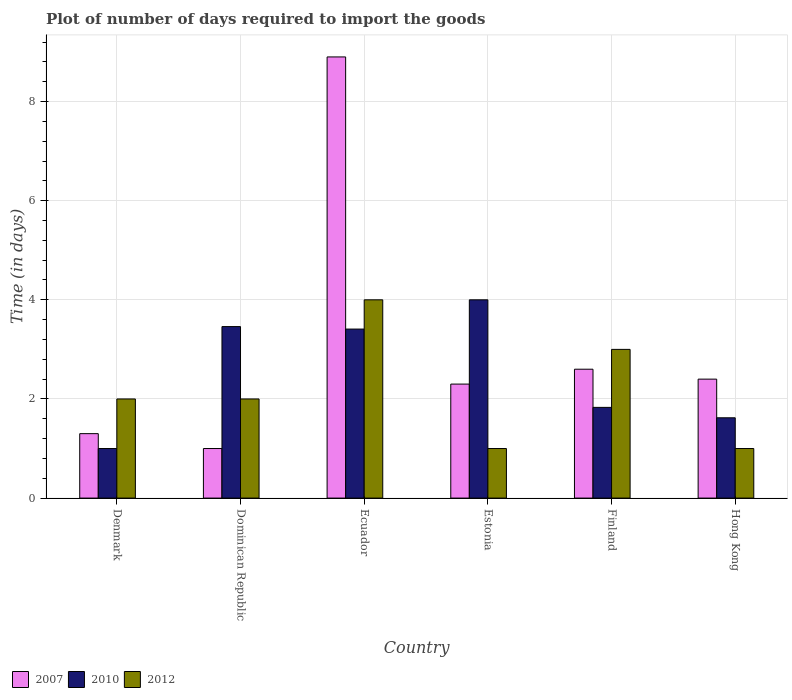How many bars are there on the 1st tick from the right?
Your answer should be compact. 3. What is the label of the 6th group of bars from the left?
Ensure brevity in your answer.  Hong Kong. Across all countries, what is the minimum time required to import goods in 2010?
Give a very brief answer. 1. In which country was the time required to import goods in 2007 maximum?
Provide a succinct answer. Ecuador. In which country was the time required to import goods in 2010 minimum?
Offer a very short reply. Denmark. What is the difference between the time required to import goods in 2007 in Ecuador and that in Estonia?
Your response must be concise. 6.6. What is the difference between the time required to import goods in 2012 in Denmark and the time required to import goods in 2010 in Ecuador?
Provide a succinct answer. -1.41. What is the average time required to import goods in 2010 per country?
Offer a terse response. 2.55. What is the difference between the time required to import goods of/in 2010 and time required to import goods of/in 2007 in Dominican Republic?
Provide a succinct answer. 2.46. What is the ratio of the time required to import goods in 2007 in Estonia to that in Hong Kong?
Your answer should be very brief. 0.96. Is the time required to import goods in 2012 in Denmark less than that in Dominican Republic?
Your answer should be compact. No. Is the difference between the time required to import goods in 2010 in Ecuador and Hong Kong greater than the difference between the time required to import goods in 2007 in Ecuador and Hong Kong?
Provide a succinct answer. No. What is the difference between the highest and the second highest time required to import goods in 2010?
Offer a very short reply. -0.05. What is the difference between the highest and the lowest time required to import goods in 2010?
Offer a very short reply. 3. In how many countries, is the time required to import goods in 2012 greater than the average time required to import goods in 2012 taken over all countries?
Ensure brevity in your answer.  2. How many bars are there?
Ensure brevity in your answer.  18. Does the graph contain grids?
Your answer should be compact. Yes. How many legend labels are there?
Offer a very short reply. 3. How are the legend labels stacked?
Give a very brief answer. Horizontal. What is the title of the graph?
Ensure brevity in your answer.  Plot of number of days required to import the goods. Does "2003" appear as one of the legend labels in the graph?
Provide a succinct answer. No. What is the label or title of the X-axis?
Offer a terse response. Country. What is the label or title of the Y-axis?
Your answer should be compact. Time (in days). What is the Time (in days) of 2007 in Denmark?
Your answer should be very brief. 1.3. What is the Time (in days) of 2007 in Dominican Republic?
Your response must be concise. 1. What is the Time (in days) of 2010 in Dominican Republic?
Ensure brevity in your answer.  3.46. What is the Time (in days) of 2007 in Ecuador?
Make the answer very short. 8.9. What is the Time (in days) in 2010 in Ecuador?
Your answer should be very brief. 3.41. What is the Time (in days) of 2007 in Estonia?
Provide a succinct answer. 2.3. What is the Time (in days) of 2010 in Estonia?
Your response must be concise. 4. What is the Time (in days) of 2012 in Estonia?
Give a very brief answer. 1. What is the Time (in days) of 2010 in Finland?
Keep it short and to the point. 1.83. What is the Time (in days) of 2010 in Hong Kong?
Offer a very short reply. 1.62. What is the Time (in days) in 2012 in Hong Kong?
Your answer should be compact. 1. Across all countries, what is the maximum Time (in days) of 2010?
Make the answer very short. 4. What is the total Time (in days) in 2010 in the graph?
Offer a very short reply. 15.32. What is the total Time (in days) of 2012 in the graph?
Your answer should be very brief. 13. What is the difference between the Time (in days) of 2007 in Denmark and that in Dominican Republic?
Your answer should be compact. 0.3. What is the difference between the Time (in days) in 2010 in Denmark and that in Dominican Republic?
Your response must be concise. -2.46. What is the difference between the Time (in days) of 2012 in Denmark and that in Dominican Republic?
Your answer should be compact. 0. What is the difference between the Time (in days) of 2010 in Denmark and that in Ecuador?
Offer a terse response. -2.41. What is the difference between the Time (in days) in 2012 in Denmark and that in Ecuador?
Your answer should be compact. -2. What is the difference between the Time (in days) of 2010 in Denmark and that in Finland?
Your answer should be compact. -0.83. What is the difference between the Time (in days) of 2012 in Denmark and that in Finland?
Your answer should be compact. -1. What is the difference between the Time (in days) of 2007 in Denmark and that in Hong Kong?
Ensure brevity in your answer.  -1.1. What is the difference between the Time (in days) of 2010 in Denmark and that in Hong Kong?
Provide a short and direct response. -0.62. What is the difference between the Time (in days) of 2012 in Denmark and that in Hong Kong?
Ensure brevity in your answer.  1. What is the difference between the Time (in days) of 2007 in Dominican Republic and that in Ecuador?
Make the answer very short. -7.9. What is the difference between the Time (in days) of 2012 in Dominican Republic and that in Ecuador?
Your answer should be very brief. -2. What is the difference between the Time (in days) of 2007 in Dominican Republic and that in Estonia?
Provide a short and direct response. -1.3. What is the difference between the Time (in days) of 2010 in Dominican Republic and that in Estonia?
Your answer should be very brief. -0.54. What is the difference between the Time (in days) of 2012 in Dominican Republic and that in Estonia?
Offer a very short reply. 1. What is the difference between the Time (in days) of 2007 in Dominican Republic and that in Finland?
Your answer should be very brief. -1.6. What is the difference between the Time (in days) of 2010 in Dominican Republic and that in Finland?
Your response must be concise. 1.63. What is the difference between the Time (in days) in 2012 in Dominican Republic and that in Finland?
Keep it short and to the point. -1. What is the difference between the Time (in days) in 2007 in Dominican Republic and that in Hong Kong?
Your response must be concise. -1.4. What is the difference between the Time (in days) of 2010 in Dominican Republic and that in Hong Kong?
Provide a succinct answer. 1.84. What is the difference between the Time (in days) in 2010 in Ecuador and that in Estonia?
Provide a short and direct response. -0.59. What is the difference between the Time (in days) in 2012 in Ecuador and that in Estonia?
Offer a terse response. 3. What is the difference between the Time (in days) in 2010 in Ecuador and that in Finland?
Your answer should be very brief. 1.58. What is the difference between the Time (in days) of 2012 in Ecuador and that in Finland?
Keep it short and to the point. 1. What is the difference between the Time (in days) in 2007 in Ecuador and that in Hong Kong?
Your answer should be very brief. 6.5. What is the difference between the Time (in days) of 2010 in Ecuador and that in Hong Kong?
Give a very brief answer. 1.79. What is the difference between the Time (in days) in 2012 in Ecuador and that in Hong Kong?
Ensure brevity in your answer.  3. What is the difference between the Time (in days) of 2007 in Estonia and that in Finland?
Provide a short and direct response. -0.3. What is the difference between the Time (in days) in 2010 in Estonia and that in Finland?
Give a very brief answer. 2.17. What is the difference between the Time (in days) of 2007 in Estonia and that in Hong Kong?
Provide a short and direct response. -0.1. What is the difference between the Time (in days) in 2010 in Estonia and that in Hong Kong?
Offer a terse response. 2.38. What is the difference between the Time (in days) of 2010 in Finland and that in Hong Kong?
Your answer should be very brief. 0.21. What is the difference between the Time (in days) of 2007 in Denmark and the Time (in days) of 2010 in Dominican Republic?
Your answer should be compact. -2.16. What is the difference between the Time (in days) in 2007 in Denmark and the Time (in days) in 2010 in Ecuador?
Your answer should be very brief. -2.11. What is the difference between the Time (in days) of 2007 in Denmark and the Time (in days) of 2012 in Estonia?
Your answer should be very brief. 0.3. What is the difference between the Time (in days) in 2007 in Denmark and the Time (in days) in 2010 in Finland?
Ensure brevity in your answer.  -0.53. What is the difference between the Time (in days) in 2007 in Denmark and the Time (in days) in 2012 in Finland?
Provide a short and direct response. -1.7. What is the difference between the Time (in days) of 2007 in Denmark and the Time (in days) of 2010 in Hong Kong?
Provide a short and direct response. -0.32. What is the difference between the Time (in days) of 2007 in Denmark and the Time (in days) of 2012 in Hong Kong?
Ensure brevity in your answer.  0.3. What is the difference between the Time (in days) of 2010 in Denmark and the Time (in days) of 2012 in Hong Kong?
Make the answer very short. 0. What is the difference between the Time (in days) of 2007 in Dominican Republic and the Time (in days) of 2010 in Ecuador?
Provide a short and direct response. -2.41. What is the difference between the Time (in days) in 2007 in Dominican Republic and the Time (in days) in 2012 in Ecuador?
Provide a succinct answer. -3. What is the difference between the Time (in days) of 2010 in Dominican Republic and the Time (in days) of 2012 in Ecuador?
Your response must be concise. -0.54. What is the difference between the Time (in days) of 2007 in Dominican Republic and the Time (in days) of 2010 in Estonia?
Ensure brevity in your answer.  -3. What is the difference between the Time (in days) of 2010 in Dominican Republic and the Time (in days) of 2012 in Estonia?
Your answer should be compact. 2.46. What is the difference between the Time (in days) of 2007 in Dominican Republic and the Time (in days) of 2010 in Finland?
Provide a short and direct response. -0.83. What is the difference between the Time (in days) of 2010 in Dominican Republic and the Time (in days) of 2012 in Finland?
Offer a terse response. 0.46. What is the difference between the Time (in days) of 2007 in Dominican Republic and the Time (in days) of 2010 in Hong Kong?
Offer a terse response. -0.62. What is the difference between the Time (in days) in 2007 in Dominican Republic and the Time (in days) in 2012 in Hong Kong?
Provide a short and direct response. 0. What is the difference between the Time (in days) in 2010 in Dominican Republic and the Time (in days) in 2012 in Hong Kong?
Give a very brief answer. 2.46. What is the difference between the Time (in days) in 2007 in Ecuador and the Time (in days) in 2012 in Estonia?
Your response must be concise. 7.9. What is the difference between the Time (in days) of 2010 in Ecuador and the Time (in days) of 2012 in Estonia?
Your answer should be very brief. 2.41. What is the difference between the Time (in days) of 2007 in Ecuador and the Time (in days) of 2010 in Finland?
Offer a very short reply. 7.07. What is the difference between the Time (in days) of 2007 in Ecuador and the Time (in days) of 2012 in Finland?
Offer a terse response. 5.9. What is the difference between the Time (in days) of 2010 in Ecuador and the Time (in days) of 2012 in Finland?
Make the answer very short. 0.41. What is the difference between the Time (in days) of 2007 in Ecuador and the Time (in days) of 2010 in Hong Kong?
Offer a terse response. 7.28. What is the difference between the Time (in days) in 2007 in Ecuador and the Time (in days) in 2012 in Hong Kong?
Your response must be concise. 7.9. What is the difference between the Time (in days) of 2010 in Ecuador and the Time (in days) of 2012 in Hong Kong?
Your answer should be very brief. 2.41. What is the difference between the Time (in days) of 2007 in Estonia and the Time (in days) of 2010 in Finland?
Keep it short and to the point. 0.47. What is the difference between the Time (in days) in 2007 in Estonia and the Time (in days) in 2012 in Finland?
Your response must be concise. -0.7. What is the difference between the Time (in days) of 2007 in Estonia and the Time (in days) of 2010 in Hong Kong?
Keep it short and to the point. 0.68. What is the difference between the Time (in days) of 2010 in Estonia and the Time (in days) of 2012 in Hong Kong?
Provide a short and direct response. 3. What is the difference between the Time (in days) of 2010 in Finland and the Time (in days) of 2012 in Hong Kong?
Keep it short and to the point. 0.83. What is the average Time (in days) in 2007 per country?
Offer a very short reply. 3.08. What is the average Time (in days) of 2010 per country?
Your answer should be very brief. 2.55. What is the average Time (in days) of 2012 per country?
Make the answer very short. 2.17. What is the difference between the Time (in days) of 2007 and Time (in days) of 2012 in Denmark?
Ensure brevity in your answer.  -0.7. What is the difference between the Time (in days) in 2010 and Time (in days) in 2012 in Denmark?
Ensure brevity in your answer.  -1. What is the difference between the Time (in days) of 2007 and Time (in days) of 2010 in Dominican Republic?
Your answer should be compact. -2.46. What is the difference between the Time (in days) of 2007 and Time (in days) of 2012 in Dominican Republic?
Provide a succinct answer. -1. What is the difference between the Time (in days) of 2010 and Time (in days) of 2012 in Dominican Republic?
Your response must be concise. 1.46. What is the difference between the Time (in days) in 2007 and Time (in days) in 2010 in Ecuador?
Offer a terse response. 5.49. What is the difference between the Time (in days) in 2010 and Time (in days) in 2012 in Ecuador?
Provide a succinct answer. -0.59. What is the difference between the Time (in days) of 2010 and Time (in days) of 2012 in Estonia?
Make the answer very short. 3. What is the difference between the Time (in days) in 2007 and Time (in days) in 2010 in Finland?
Give a very brief answer. 0.77. What is the difference between the Time (in days) in 2010 and Time (in days) in 2012 in Finland?
Give a very brief answer. -1.17. What is the difference between the Time (in days) of 2007 and Time (in days) of 2010 in Hong Kong?
Ensure brevity in your answer.  0.78. What is the difference between the Time (in days) in 2010 and Time (in days) in 2012 in Hong Kong?
Provide a succinct answer. 0.62. What is the ratio of the Time (in days) of 2007 in Denmark to that in Dominican Republic?
Make the answer very short. 1.3. What is the ratio of the Time (in days) of 2010 in Denmark to that in Dominican Republic?
Your answer should be compact. 0.29. What is the ratio of the Time (in days) of 2012 in Denmark to that in Dominican Republic?
Your answer should be compact. 1. What is the ratio of the Time (in days) in 2007 in Denmark to that in Ecuador?
Provide a short and direct response. 0.15. What is the ratio of the Time (in days) in 2010 in Denmark to that in Ecuador?
Offer a terse response. 0.29. What is the ratio of the Time (in days) in 2012 in Denmark to that in Ecuador?
Keep it short and to the point. 0.5. What is the ratio of the Time (in days) of 2007 in Denmark to that in Estonia?
Your response must be concise. 0.57. What is the ratio of the Time (in days) of 2010 in Denmark to that in Estonia?
Your answer should be compact. 0.25. What is the ratio of the Time (in days) in 2007 in Denmark to that in Finland?
Make the answer very short. 0.5. What is the ratio of the Time (in days) in 2010 in Denmark to that in Finland?
Provide a short and direct response. 0.55. What is the ratio of the Time (in days) of 2007 in Denmark to that in Hong Kong?
Give a very brief answer. 0.54. What is the ratio of the Time (in days) of 2010 in Denmark to that in Hong Kong?
Provide a short and direct response. 0.62. What is the ratio of the Time (in days) of 2012 in Denmark to that in Hong Kong?
Give a very brief answer. 2. What is the ratio of the Time (in days) in 2007 in Dominican Republic to that in Ecuador?
Ensure brevity in your answer.  0.11. What is the ratio of the Time (in days) of 2010 in Dominican Republic to that in Ecuador?
Your answer should be very brief. 1.01. What is the ratio of the Time (in days) in 2007 in Dominican Republic to that in Estonia?
Keep it short and to the point. 0.43. What is the ratio of the Time (in days) of 2010 in Dominican Republic to that in Estonia?
Make the answer very short. 0.86. What is the ratio of the Time (in days) in 2012 in Dominican Republic to that in Estonia?
Give a very brief answer. 2. What is the ratio of the Time (in days) in 2007 in Dominican Republic to that in Finland?
Keep it short and to the point. 0.38. What is the ratio of the Time (in days) of 2010 in Dominican Republic to that in Finland?
Ensure brevity in your answer.  1.89. What is the ratio of the Time (in days) of 2007 in Dominican Republic to that in Hong Kong?
Provide a short and direct response. 0.42. What is the ratio of the Time (in days) of 2010 in Dominican Republic to that in Hong Kong?
Keep it short and to the point. 2.14. What is the ratio of the Time (in days) of 2012 in Dominican Republic to that in Hong Kong?
Offer a terse response. 2. What is the ratio of the Time (in days) in 2007 in Ecuador to that in Estonia?
Give a very brief answer. 3.87. What is the ratio of the Time (in days) of 2010 in Ecuador to that in Estonia?
Provide a succinct answer. 0.85. What is the ratio of the Time (in days) in 2007 in Ecuador to that in Finland?
Offer a terse response. 3.42. What is the ratio of the Time (in days) in 2010 in Ecuador to that in Finland?
Give a very brief answer. 1.86. What is the ratio of the Time (in days) of 2007 in Ecuador to that in Hong Kong?
Make the answer very short. 3.71. What is the ratio of the Time (in days) of 2010 in Ecuador to that in Hong Kong?
Ensure brevity in your answer.  2.1. What is the ratio of the Time (in days) in 2007 in Estonia to that in Finland?
Provide a succinct answer. 0.88. What is the ratio of the Time (in days) of 2010 in Estonia to that in Finland?
Ensure brevity in your answer.  2.19. What is the ratio of the Time (in days) in 2007 in Estonia to that in Hong Kong?
Give a very brief answer. 0.96. What is the ratio of the Time (in days) in 2010 in Estonia to that in Hong Kong?
Provide a short and direct response. 2.47. What is the ratio of the Time (in days) in 2012 in Estonia to that in Hong Kong?
Provide a succinct answer. 1. What is the ratio of the Time (in days) in 2010 in Finland to that in Hong Kong?
Offer a terse response. 1.13. What is the ratio of the Time (in days) of 2012 in Finland to that in Hong Kong?
Ensure brevity in your answer.  3. What is the difference between the highest and the second highest Time (in days) in 2010?
Keep it short and to the point. 0.54. What is the difference between the highest and the lowest Time (in days) in 2007?
Ensure brevity in your answer.  7.9. 